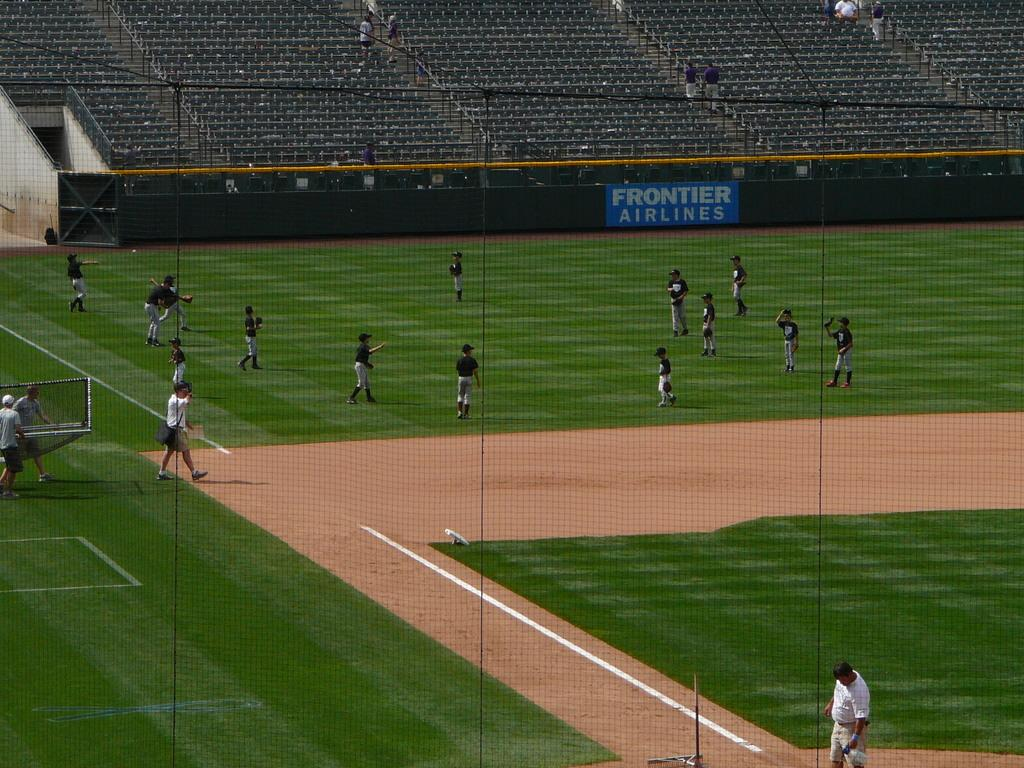<image>
Describe the image concisely. A baseball field with players practicing on it. 